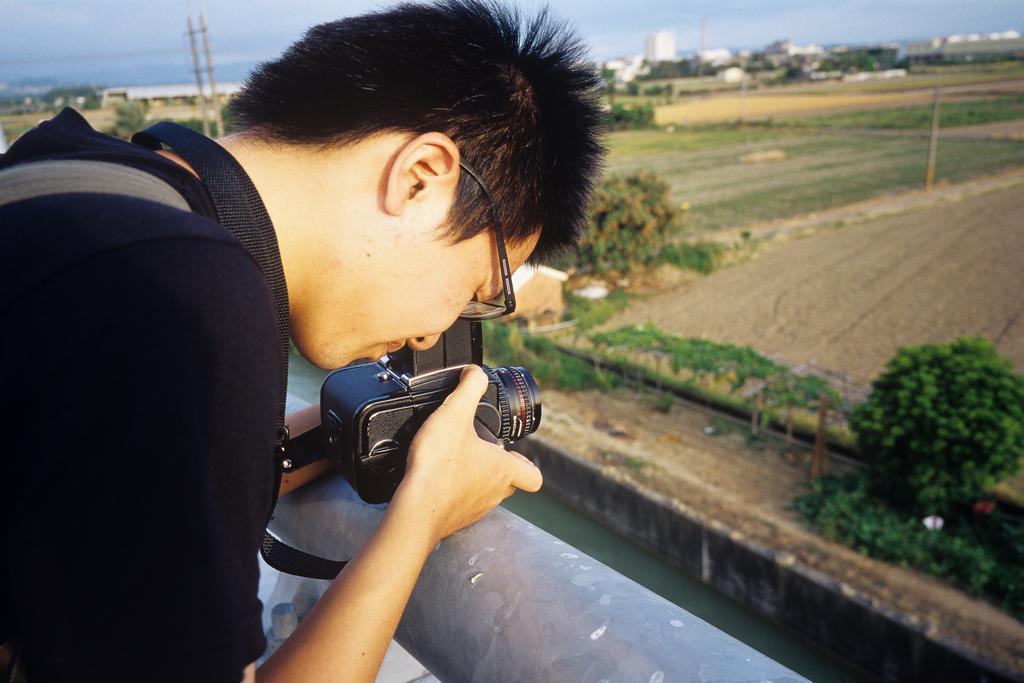Describe this image in one or two sentences. In this image the man is standing and looking into the camera which is in his hand which is in his hand. In front of him there are farms,trees,water,buildings,pole and sky. 